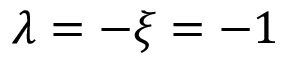<formula> <loc_0><loc_0><loc_500><loc_500>\lambda = - \xi = - 1</formula> 